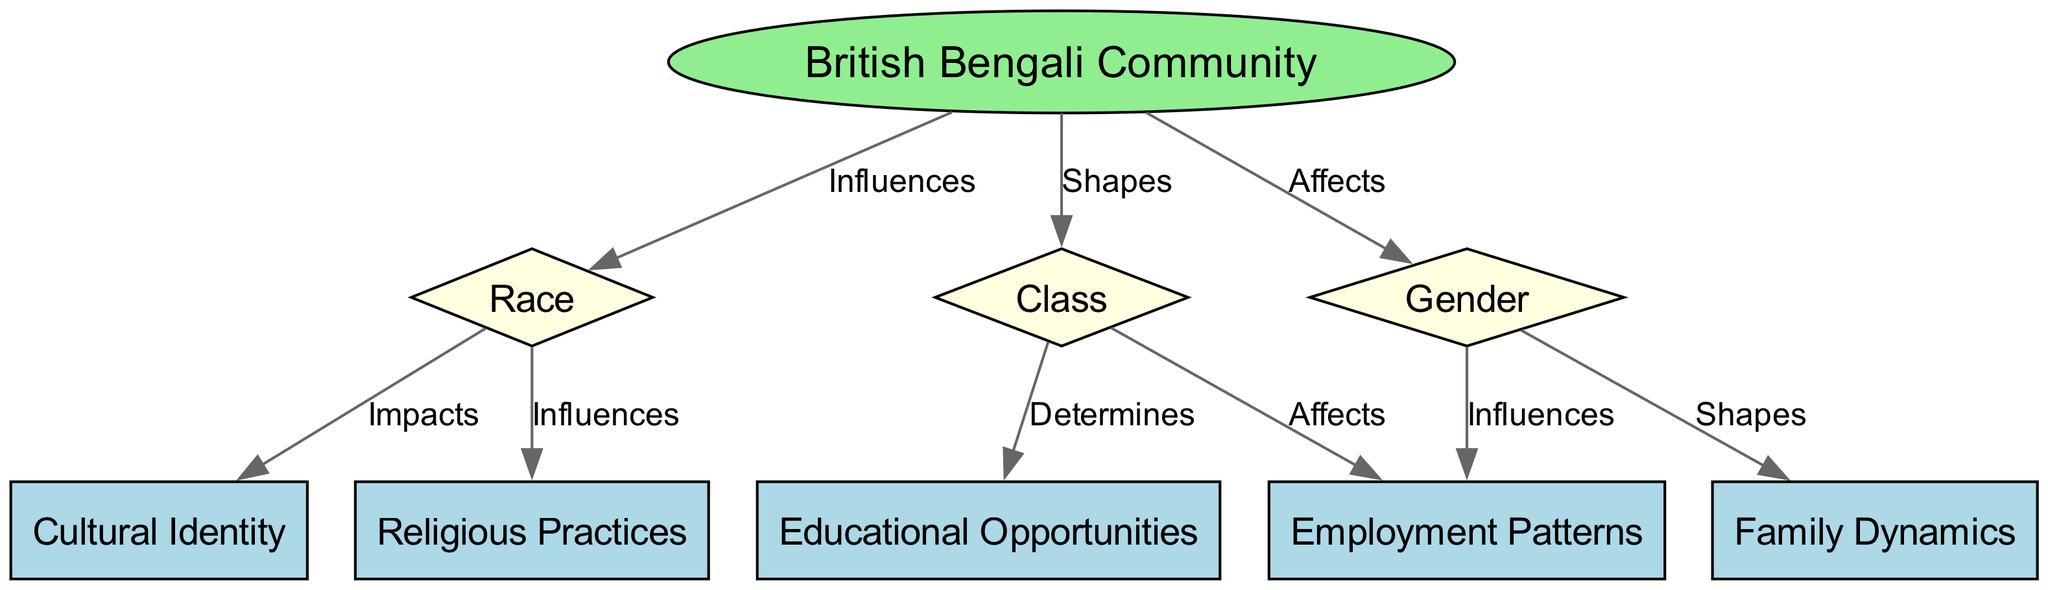What is the main community represented in the diagram? The diagram centers on the "British Bengali Community," which is clearly indicated as the primary node.
Answer: British Bengali Community How many nodes are there in total? By counting the nodes listed in the diagram, we see that there are 9 distinct nodes representing various aspects of the community.
Answer: 9 What influences employment patterns according to the diagram? The edges indicate that both "Gender" and "Class" nodes have direct connections to the "Employment Patterns" node, signifying their influence on it.
Answer: Gender, Class What shapes family dynamics in the British Bengali community? The relationship shows that the "Gender" node has a direct edge labeled "Shapes" linked to the "Family Dynamics" node, indicating gender's role in shaping family structures.
Answer: Gender Which factor impacts cultural identity in the community? The diagram shows that "Race" has a direct edge labeled "Impacts" leading to "Cultural Identity," demonstrating that race influences cultural aspects within the community.
Answer: Race What determines educational opportunities in the context of class? The edge from "Class" to "Educational Opportunities" is labeled "Determines," highlighting that class is a key factor influencing educational access and prospects.
Answer: Class Which two nodes indicate an influence on religious practices? The edge from "Race" to "Religion" indicates that race influences religious practices, making it the linking factor in this relationship.
Answer: Race How many edges connect the British Bengali community to other dimensions? The diagram illustrates that the "British Bengali Community" node has three edges linking it to the dimensions of Race, Class, and Gender, depicting their connections.
Answer: 3 What are the two influences on employment patterns in the community? The edges indicate that both "Gender" and "Class" influence "Employment Patterns," highlighting the intersection of these two aspects in the job market within the community.
Answer: Gender, Class 